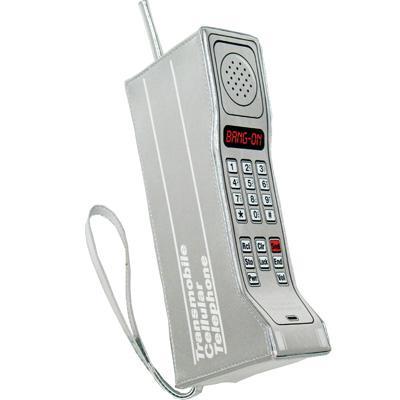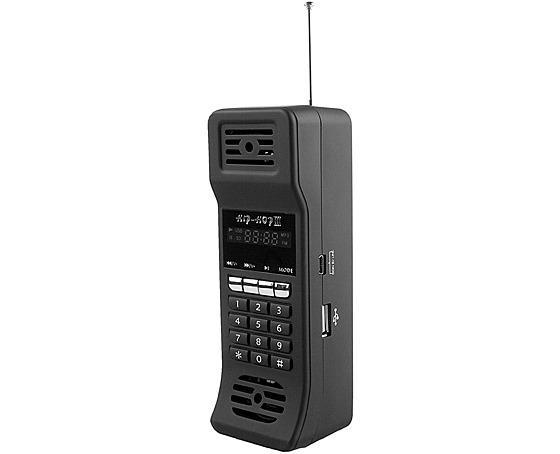The first image is the image on the left, the second image is the image on the right. For the images displayed, is the sentence "The left and right image contains the same number of phones." factually correct? Answer yes or no. Yes. The first image is the image on the left, the second image is the image on the right. For the images displayed, is the sentence "Each image contains only a single phone with an antennae on top and a flat, rectangular base." factually correct? Answer yes or no. Yes. 